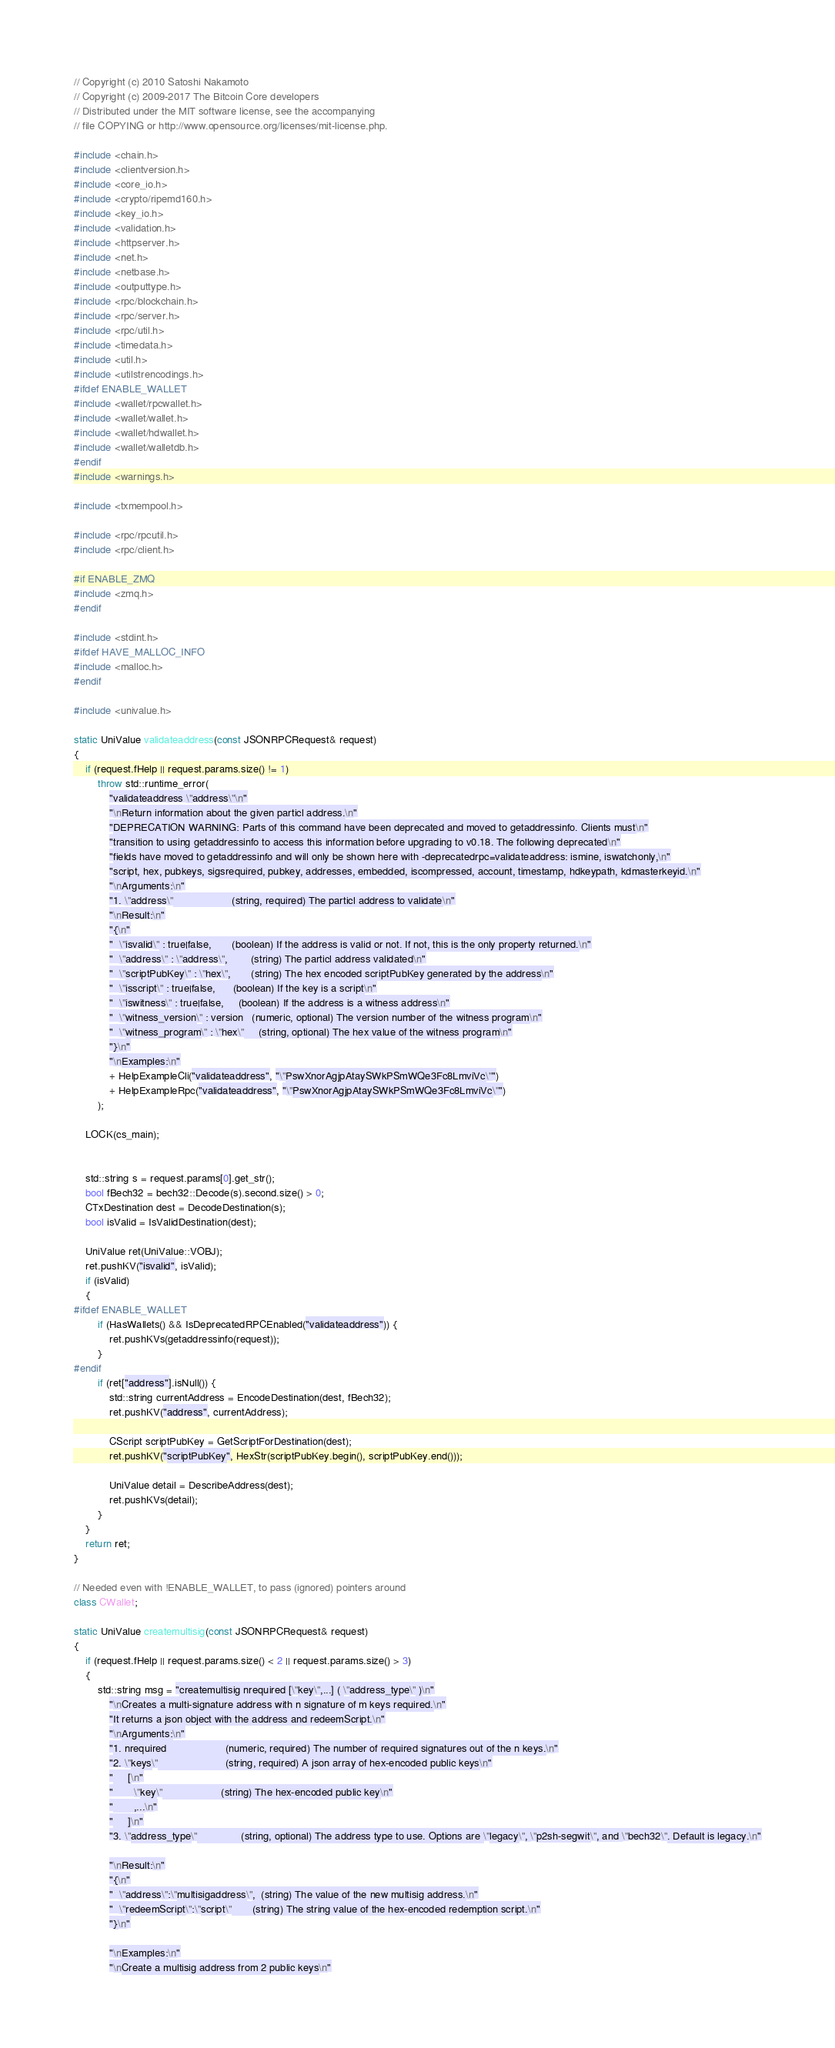<code> <loc_0><loc_0><loc_500><loc_500><_C++_>// Copyright (c) 2010 Satoshi Nakamoto
// Copyright (c) 2009-2017 The Bitcoin Core developers
// Distributed under the MIT software license, see the accompanying
// file COPYING or http://www.opensource.org/licenses/mit-license.php.

#include <chain.h>
#include <clientversion.h>
#include <core_io.h>
#include <crypto/ripemd160.h>
#include <key_io.h>
#include <validation.h>
#include <httpserver.h>
#include <net.h>
#include <netbase.h>
#include <outputtype.h>
#include <rpc/blockchain.h>
#include <rpc/server.h>
#include <rpc/util.h>
#include <timedata.h>
#include <util.h>
#include <utilstrencodings.h>
#ifdef ENABLE_WALLET
#include <wallet/rpcwallet.h>
#include <wallet/wallet.h>
#include <wallet/hdwallet.h>
#include <wallet/walletdb.h>
#endif
#include <warnings.h>

#include <txmempool.h>

#include <rpc/rpcutil.h>
#include <rpc/client.h>

#if ENABLE_ZMQ
#include <zmq.h>
#endif

#include <stdint.h>
#ifdef HAVE_MALLOC_INFO
#include <malloc.h>
#endif

#include <univalue.h>

static UniValue validateaddress(const JSONRPCRequest& request)
{
    if (request.fHelp || request.params.size() != 1)
        throw std::runtime_error(
            "validateaddress \"address\"\n"
            "\nReturn information about the given particl address.\n"
            "DEPRECATION WARNING: Parts of this command have been deprecated and moved to getaddressinfo. Clients must\n"
            "transition to using getaddressinfo to access this information before upgrading to v0.18. The following deprecated\n"
            "fields have moved to getaddressinfo and will only be shown here with -deprecatedrpc=validateaddress: ismine, iswatchonly,\n"
            "script, hex, pubkeys, sigsrequired, pubkey, addresses, embedded, iscompressed, account, timestamp, hdkeypath, kdmasterkeyid.\n"
            "\nArguments:\n"
            "1. \"address\"                    (string, required) The particl address to validate\n"
            "\nResult:\n"
            "{\n"
            "  \"isvalid\" : true|false,       (boolean) If the address is valid or not. If not, this is the only property returned.\n"
            "  \"address\" : \"address\",        (string) The particl address validated\n"
            "  \"scriptPubKey\" : \"hex\",       (string) The hex encoded scriptPubKey generated by the address\n"
            "  \"isscript\" : true|false,      (boolean) If the key is a script\n"
            "  \"iswitness\" : true|false,     (boolean) If the address is a witness address\n"
            "  \"witness_version\" : version   (numeric, optional) The version number of the witness program\n"
            "  \"witness_program\" : \"hex\"     (string, optional) The hex value of the witness program\n"
            "}\n"
            "\nExamples:\n"
            + HelpExampleCli("validateaddress", "\"PswXnorAgjpAtaySWkPSmWQe3Fc8LmviVc\"")
            + HelpExampleRpc("validateaddress", "\"PswXnorAgjpAtaySWkPSmWQe3Fc8LmviVc\"")
        );

    LOCK(cs_main);


    std::string s = request.params[0].get_str();
    bool fBech32 = bech32::Decode(s).second.size() > 0;
    CTxDestination dest = DecodeDestination(s);
    bool isValid = IsValidDestination(dest);

    UniValue ret(UniValue::VOBJ);
    ret.pushKV("isvalid", isValid);
    if (isValid)
    {
#ifdef ENABLE_WALLET
        if (HasWallets() && IsDeprecatedRPCEnabled("validateaddress")) {
            ret.pushKVs(getaddressinfo(request));
        }
#endif
        if (ret["address"].isNull()) {
            std::string currentAddress = EncodeDestination(dest, fBech32);
            ret.pushKV("address", currentAddress);

            CScript scriptPubKey = GetScriptForDestination(dest);
            ret.pushKV("scriptPubKey", HexStr(scriptPubKey.begin(), scriptPubKey.end()));

            UniValue detail = DescribeAddress(dest);
            ret.pushKVs(detail);
        }
    }
    return ret;
}

// Needed even with !ENABLE_WALLET, to pass (ignored) pointers around
class CWallet;

static UniValue createmultisig(const JSONRPCRequest& request)
{
    if (request.fHelp || request.params.size() < 2 || request.params.size() > 3)
    {
        std::string msg = "createmultisig nrequired [\"key\",...] ( \"address_type\" )\n"
            "\nCreates a multi-signature address with n signature of m keys required.\n"
            "It returns a json object with the address and redeemScript.\n"
            "\nArguments:\n"
            "1. nrequired                    (numeric, required) The number of required signatures out of the n keys.\n"
            "2. \"keys\"                       (string, required) A json array of hex-encoded public keys\n"
            "     [\n"
            "       \"key\"                    (string) The hex-encoded public key\n"
            "       ,...\n"
            "     ]\n"
            "3. \"address_type\"               (string, optional) The address type to use. Options are \"legacy\", \"p2sh-segwit\", and \"bech32\". Default is legacy.\n"

            "\nResult:\n"
            "{\n"
            "  \"address\":\"multisigaddress\",  (string) The value of the new multisig address.\n"
            "  \"redeemScript\":\"script\"       (string) The string value of the hex-encoded redemption script.\n"
            "}\n"

            "\nExamples:\n"
            "\nCreate a multisig address from 2 public keys\n"</code> 